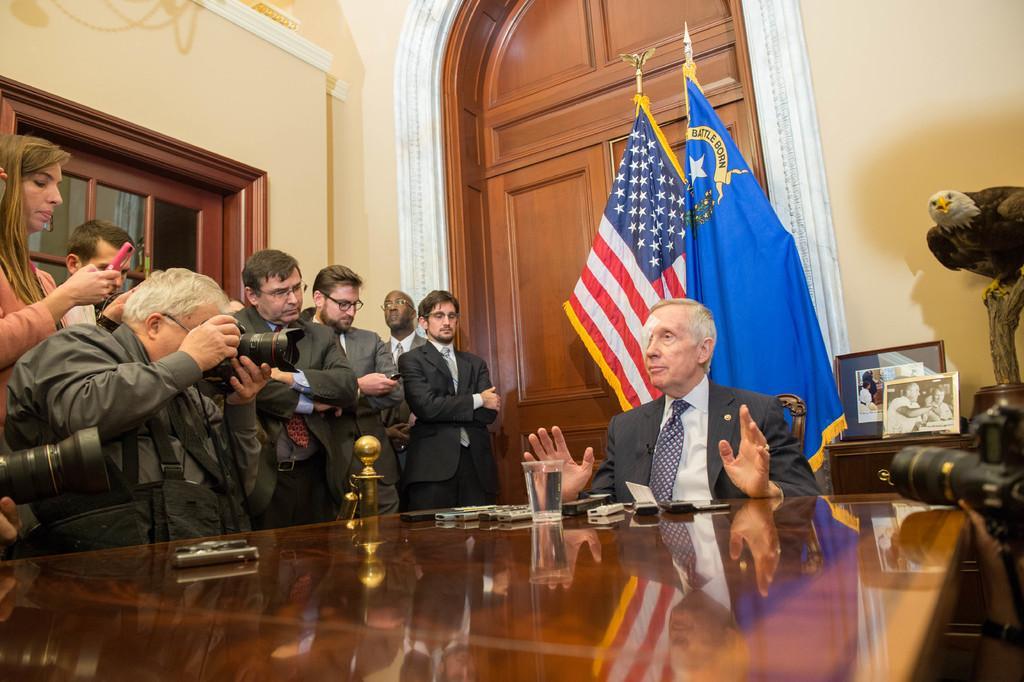How would you summarize this image in a sentence or two? In this picture we can see a person sitting on a chair. There is a phone,wallet, glass and other objects on the table. We can see some people standing on the left side. There are few people holding cameras in their hands. A woman is holding a phone in her hand on the left side. There are frames on a wooden desk. We can see an idol on the right side. There are two flags and an arch in the background. 